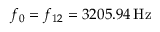<formula> <loc_0><loc_0><loc_500><loc_500>f _ { 0 } = f _ { 1 2 } = 3 2 0 5 . 9 4 \, H z</formula> 